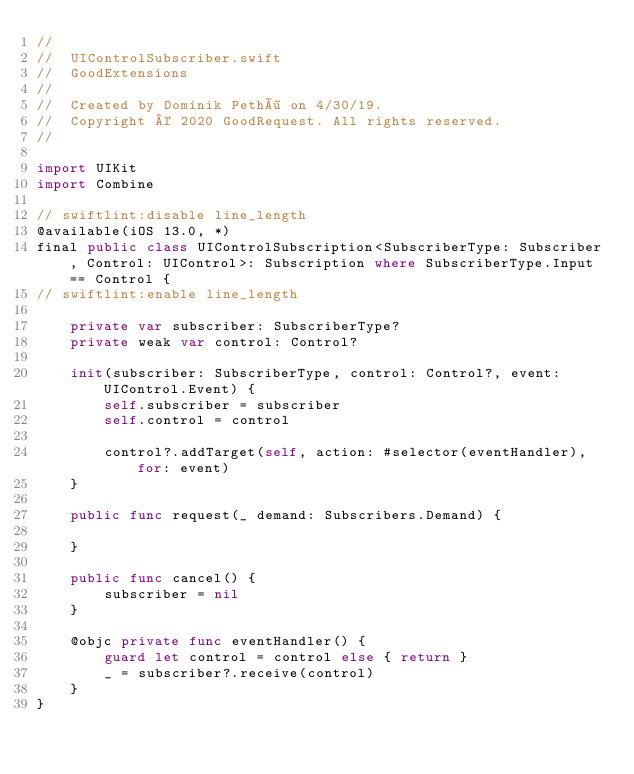<code> <loc_0><loc_0><loc_500><loc_500><_Swift_>//
//  UIControlSubscriber.swift
//  GoodExtensions
//
//  Created by Dominik Pethö on 4/30/19.
//  Copyright © 2020 GoodRequest. All rights reserved.
//

import UIKit
import Combine

// swiftlint:disable line_length
@available(iOS 13.0, *)
final public class UIControlSubscription<SubscriberType: Subscriber, Control: UIControl>: Subscription where SubscriberType.Input == Control {
// swiftlint:enable line_length

    private var subscriber: SubscriberType?
    private weak var control: Control?

    init(subscriber: SubscriberType, control: Control?, event: UIControl.Event) {
        self.subscriber = subscriber
        self.control = control

        control?.addTarget(self, action: #selector(eventHandler), for: event)
    }

    public func request(_ demand: Subscribers.Demand) {

    }

    public func cancel() {
        subscriber = nil
    }

    @objc private func eventHandler() {
        guard let control = control else { return }
        _ = subscriber?.receive(control)
    }
}
</code> 